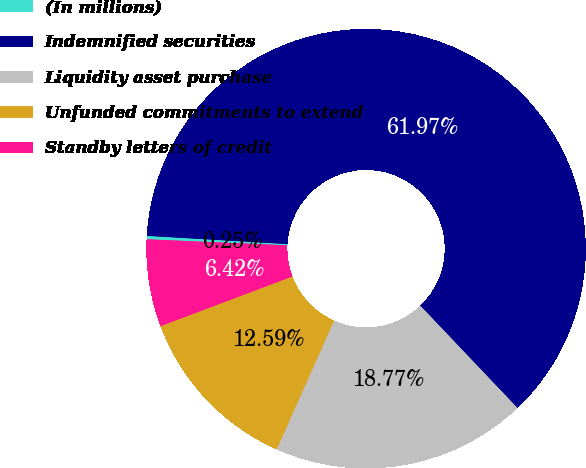Convert chart to OTSL. <chart><loc_0><loc_0><loc_500><loc_500><pie_chart><fcel>(In millions)<fcel>Indemnified securities<fcel>Liquidity asset purchase<fcel>Unfunded commitments to extend<fcel>Standby letters of credit<nl><fcel>0.25%<fcel>61.98%<fcel>18.77%<fcel>12.59%<fcel>6.42%<nl></chart> 